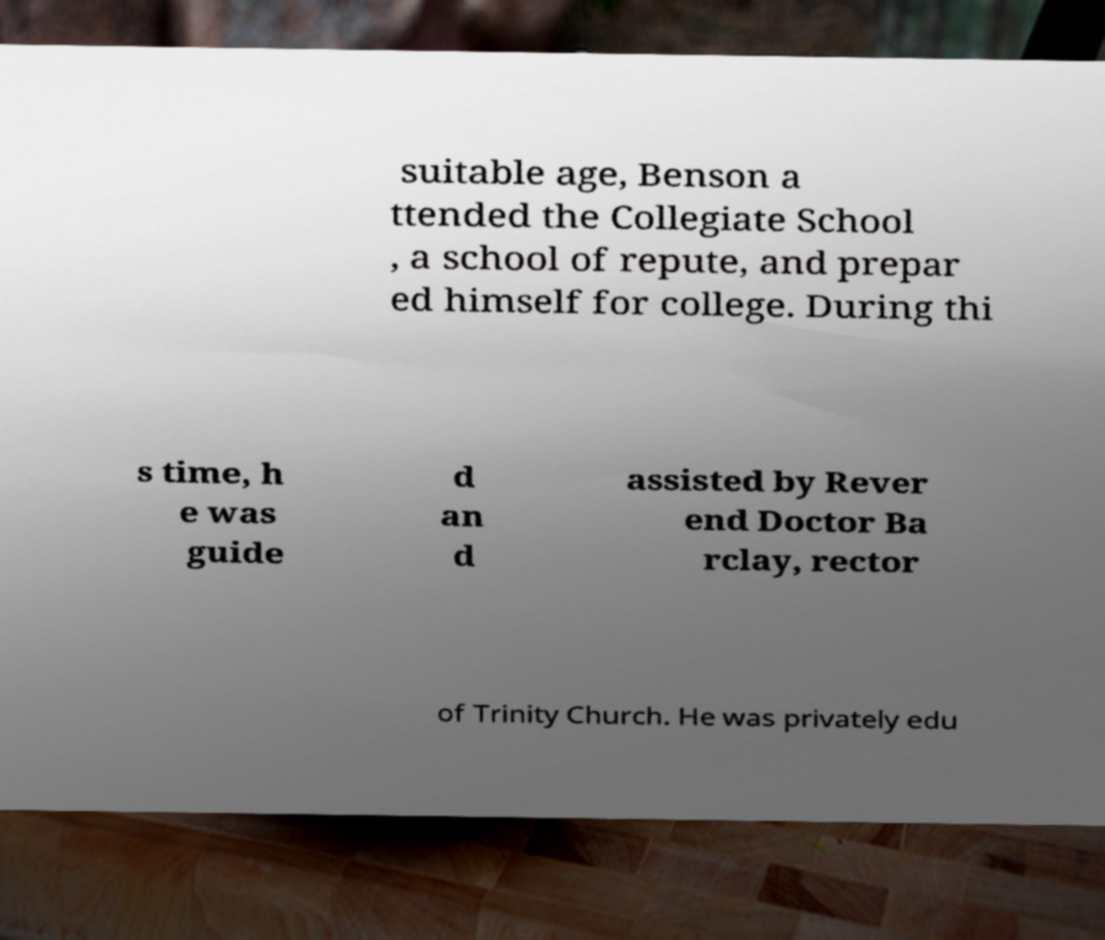Please read and relay the text visible in this image. What does it say? suitable age, Benson a ttended the Collegiate School , a school of repute, and prepar ed himself for college. During thi s time, h e was guide d an d assisted by Rever end Doctor Ba rclay, rector of Trinity Church. He was privately edu 